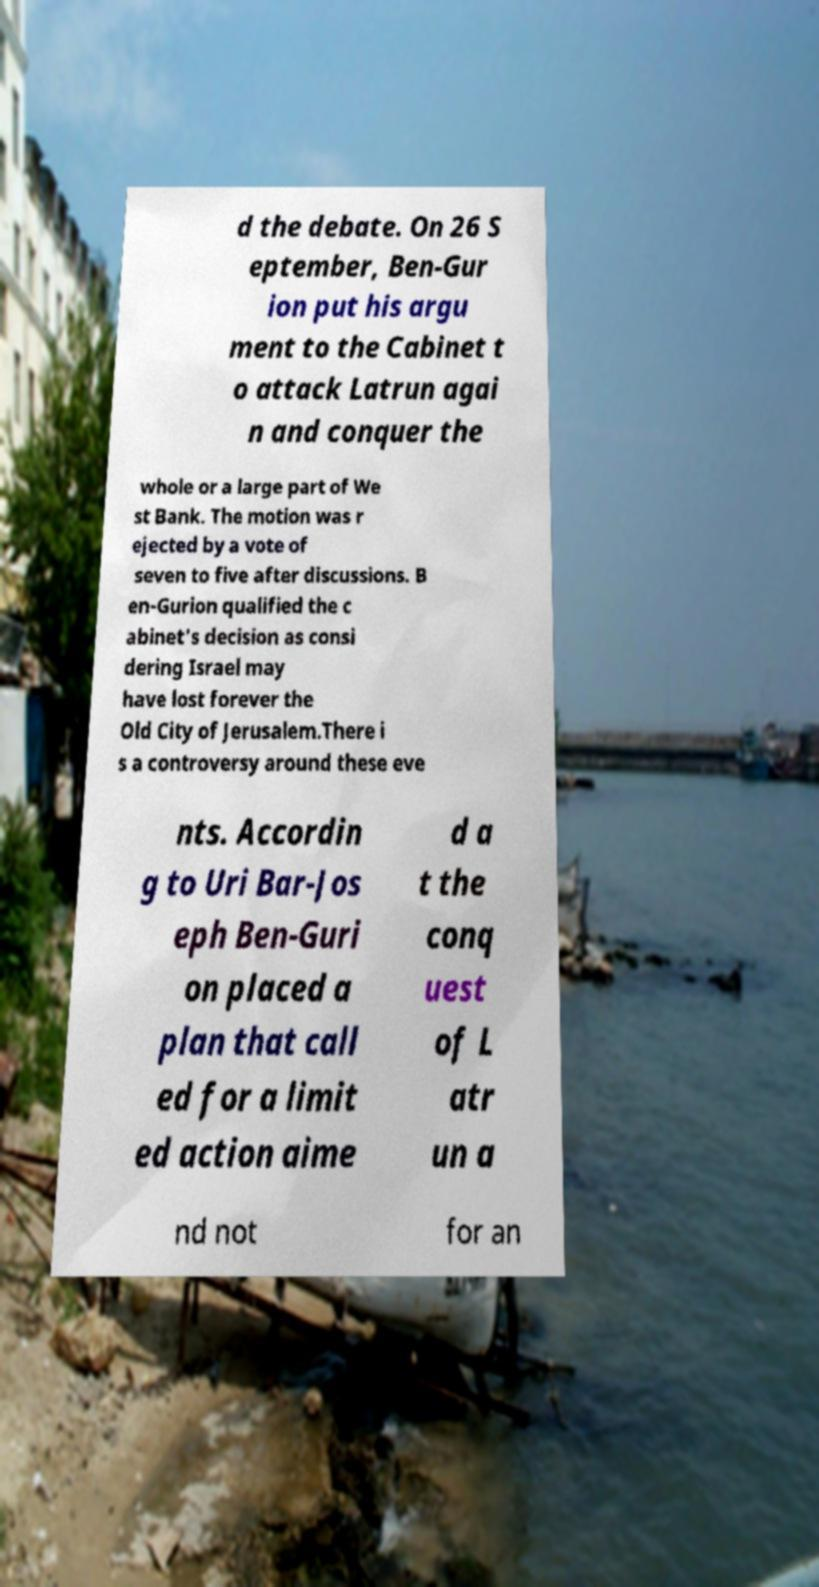Could you extract and type out the text from this image? d the debate. On 26 S eptember, Ben-Gur ion put his argu ment to the Cabinet t o attack Latrun agai n and conquer the whole or a large part of We st Bank. The motion was r ejected by a vote of seven to five after discussions. B en-Gurion qualified the c abinet's decision as consi dering Israel may have lost forever the Old City of Jerusalem.There i s a controversy around these eve nts. Accordin g to Uri Bar-Jos eph Ben-Guri on placed a plan that call ed for a limit ed action aime d a t the conq uest of L atr un a nd not for an 